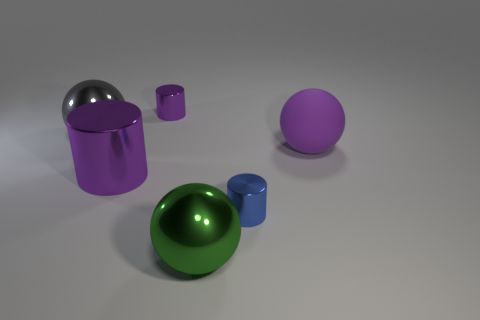There is a purple shiny thing in front of the tiny purple cylinder; is its shape the same as the small blue thing that is in front of the big rubber object?
Provide a short and direct response. Yes. There is a object that is behind the blue cylinder and to the right of the green metallic sphere; what color is it?
Offer a terse response. Purple. Is the color of the rubber object the same as the tiny shiny cylinder that is in front of the large rubber thing?
Ensure brevity in your answer.  No. There is a shiny object that is both behind the large green thing and in front of the big purple cylinder; what is its size?
Your response must be concise. Small. How many other objects are there of the same color as the matte thing?
Your answer should be very brief. 2. There is a purple metal cylinder that is behind the shiny sphere that is left of the large purple thing that is left of the big matte sphere; how big is it?
Make the answer very short. Small. There is a big matte object; are there any gray balls on the right side of it?
Provide a short and direct response. No. There is a purple rubber thing; does it have the same size as the metal sphere that is behind the tiny blue metal thing?
Give a very brief answer. Yes. What number of other things are the same material as the blue object?
Ensure brevity in your answer.  4. What is the shape of the purple object that is both in front of the gray metal sphere and left of the tiny blue metallic thing?
Your response must be concise. Cylinder. 